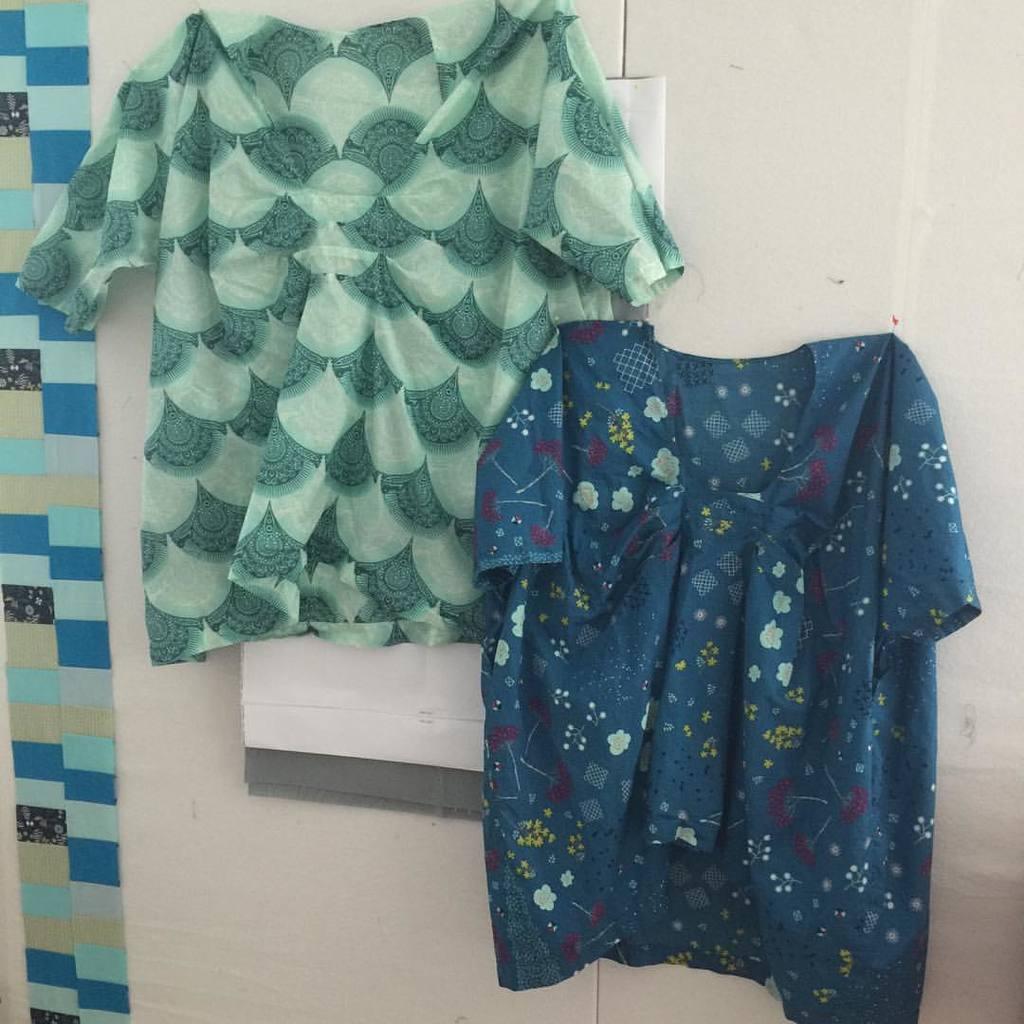Please provide a concise description of this image. In this image we can see there are two shirts hung on the wall and on the left side of the image there are color blocks on it. 